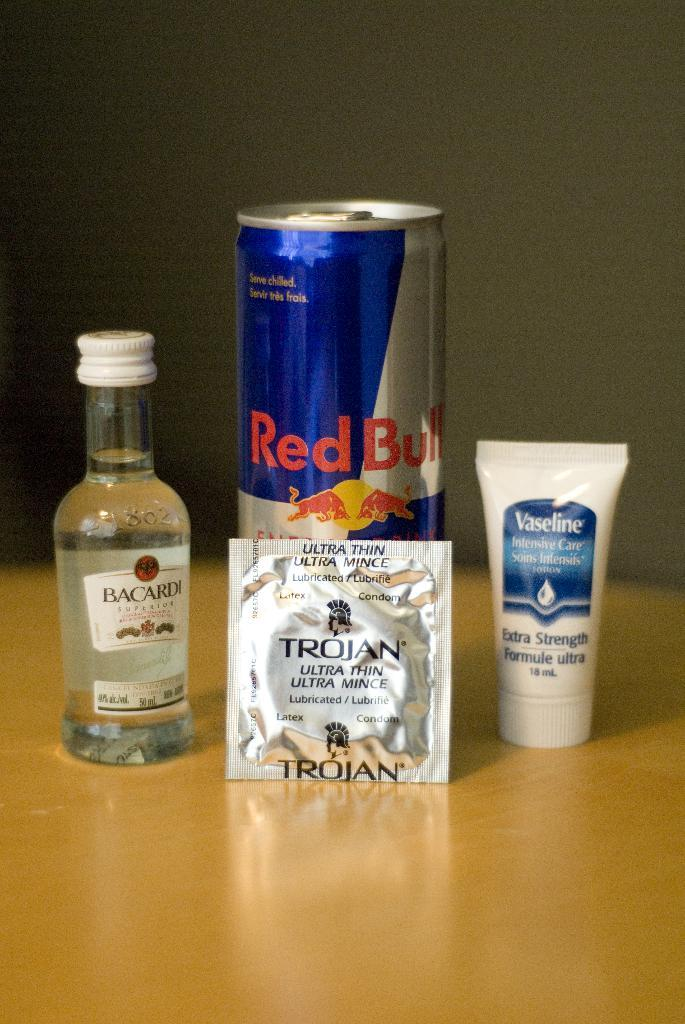What type of beverage can is present in the image? There is a red bull can in the image. What type of alcoholic beverage is represented by the glass bottle in the image? There is a bacardi glass bottle in the image. What is the small, sealed package in the image? There is a sachet in the image. What type of product is in a tube-like container in the image? There is a vaseline cream product in the image. Where are all these objects located in the image? All these objects are on a table. What type of owl can be seen controlling the red bull can in the image? There is no owl present in the image, and the red bull can is not being controlled by any creature. 